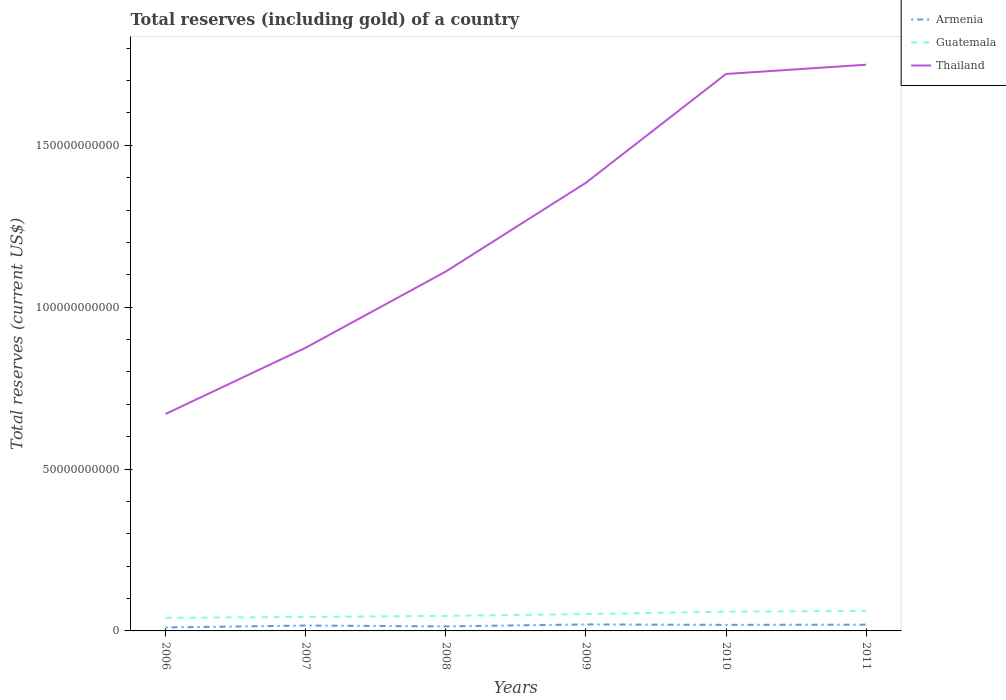Does the line corresponding to Armenia intersect with the line corresponding to Thailand?
Provide a succinct answer. No. Is the number of lines equal to the number of legend labels?
Your response must be concise. Yes. Across all years, what is the maximum total reserves (including gold) in Guatemala?
Your answer should be compact. 4.06e+09. What is the total total reserves (including gold) in Thailand in the graph?
Your response must be concise. -8.74e+1. What is the difference between the highest and the second highest total reserves (including gold) in Armenia?
Make the answer very short. 9.32e+08. How many lines are there?
Provide a succinct answer. 3. How many years are there in the graph?
Keep it short and to the point. 6. What is the difference between two consecutive major ticks on the Y-axis?
Your answer should be very brief. 5.00e+1. Are the values on the major ticks of Y-axis written in scientific E-notation?
Provide a succinct answer. No. Does the graph contain any zero values?
Give a very brief answer. No. Does the graph contain grids?
Provide a short and direct response. No. What is the title of the graph?
Give a very brief answer. Total reserves (including gold) of a country. Does "Iraq" appear as one of the legend labels in the graph?
Give a very brief answer. No. What is the label or title of the Y-axis?
Your response must be concise. Total reserves (current US$). What is the Total reserves (current US$) in Armenia in 2006?
Keep it short and to the point. 1.07e+09. What is the Total reserves (current US$) in Guatemala in 2006?
Give a very brief answer. 4.06e+09. What is the Total reserves (current US$) of Thailand in 2006?
Ensure brevity in your answer.  6.70e+1. What is the Total reserves (current US$) in Armenia in 2007?
Your answer should be compact. 1.66e+09. What is the Total reserves (current US$) of Guatemala in 2007?
Keep it short and to the point. 4.31e+09. What is the Total reserves (current US$) in Thailand in 2007?
Your answer should be very brief. 8.75e+1. What is the Total reserves (current US$) of Armenia in 2008?
Provide a succinct answer. 1.41e+09. What is the Total reserves (current US$) of Guatemala in 2008?
Make the answer very short. 4.65e+09. What is the Total reserves (current US$) of Thailand in 2008?
Provide a short and direct response. 1.11e+11. What is the Total reserves (current US$) of Armenia in 2009?
Give a very brief answer. 2.00e+09. What is the Total reserves (current US$) of Guatemala in 2009?
Your answer should be very brief. 5.20e+09. What is the Total reserves (current US$) in Thailand in 2009?
Provide a short and direct response. 1.38e+11. What is the Total reserves (current US$) of Armenia in 2010?
Offer a terse response. 1.87e+09. What is the Total reserves (current US$) of Guatemala in 2010?
Ensure brevity in your answer.  5.95e+09. What is the Total reserves (current US$) in Thailand in 2010?
Your response must be concise. 1.72e+11. What is the Total reserves (current US$) in Armenia in 2011?
Offer a terse response. 1.93e+09. What is the Total reserves (current US$) in Guatemala in 2011?
Ensure brevity in your answer.  6.17e+09. What is the Total reserves (current US$) of Thailand in 2011?
Make the answer very short. 1.75e+11. Across all years, what is the maximum Total reserves (current US$) of Armenia?
Ensure brevity in your answer.  2.00e+09. Across all years, what is the maximum Total reserves (current US$) of Guatemala?
Your answer should be compact. 6.17e+09. Across all years, what is the maximum Total reserves (current US$) of Thailand?
Make the answer very short. 1.75e+11. Across all years, what is the minimum Total reserves (current US$) of Armenia?
Provide a short and direct response. 1.07e+09. Across all years, what is the minimum Total reserves (current US$) of Guatemala?
Offer a very short reply. 4.06e+09. Across all years, what is the minimum Total reserves (current US$) in Thailand?
Offer a terse response. 6.70e+1. What is the total Total reserves (current US$) in Armenia in the graph?
Provide a succinct answer. 9.94e+09. What is the total Total reserves (current US$) in Guatemala in the graph?
Offer a very short reply. 3.04e+1. What is the total Total reserves (current US$) of Thailand in the graph?
Your answer should be compact. 7.51e+11. What is the difference between the Total reserves (current US$) of Armenia in 2006 and that in 2007?
Provide a short and direct response. -5.87e+08. What is the difference between the Total reserves (current US$) of Guatemala in 2006 and that in 2007?
Keep it short and to the point. -2.59e+08. What is the difference between the Total reserves (current US$) in Thailand in 2006 and that in 2007?
Keep it short and to the point. -2.05e+1. What is the difference between the Total reserves (current US$) of Armenia in 2006 and that in 2008?
Make the answer very short. -3.35e+08. What is the difference between the Total reserves (current US$) of Guatemala in 2006 and that in 2008?
Make the answer very short. -5.99e+08. What is the difference between the Total reserves (current US$) in Thailand in 2006 and that in 2008?
Provide a short and direct response. -4.40e+1. What is the difference between the Total reserves (current US$) in Armenia in 2006 and that in 2009?
Your answer should be very brief. -9.32e+08. What is the difference between the Total reserves (current US$) in Guatemala in 2006 and that in 2009?
Your answer should be compact. -1.15e+09. What is the difference between the Total reserves (current US$) in Thailand in 2006 and that in 2009?
Make the answer very short. -7.14e+1. What is the difference between the Total reserves (current US$) of Armenia in 2006 and that in 2010?
Your answer should be compact. -7.94e+08. What is the difference between the Total reserves (current US$) in Guatemala in 2006 and that in 2010?
Provide a short and direct response. -1.89e+09. What is the difference between the Total reserves (current US$) of Thailand in 2006 and that in 2010?
Your answer should be compact. -1.05e+11. What is the difference between the Total reserves (current US$) of Armenia in 2006 and that in 2011?
Make the answer very short. -8.61e+08. What is the difference between the Total reserves (current US$) in Guatemala in 2006 and that in 2011?
Give a very brief answer. -2.12e+09. What is the difference between the Total reserves (current US$) in Thailand in 2006 and that in 2011?
Your response must be concise. -1.08e+11. What is the difference between the Total reserves (current US$) of Armenia in 2007 and that in 2008?
Your answer should be very brief. 2.52e+08. What is the difference between the Total reserves (current US$) of Guatemala in 2007 and that in 2008?
Your answer should be compact. -3.39e+08. What is the difference between the Total reserves (current US$) of Thailand in 2007 and that in 2008?
Give a very brief answer. -2.35e+1. What is the difference between the Total reserves (current US$) in Armenia in 2007 and that in 2009?
Your response must be concise. -3.45e+08. What is the difference between the Total reserves (current US$) in Guatemala in 2007 and that in 2009?
Your response must be concise. -8.90e+08. What is the difference between the Total reserves (current US$) of Thailand in 2007 and that in 2009?
Your answer should be very brief. -5.09e+1. What is the difference between the Total reserves (current US$) in Armenia in 2007 and that in 2010?
Make the answer very short. -2.07e+08. What is the difference between the Total reserves (current US$) in Guatemala in 2007 and that in 2010?
Give a very brief answer. -1.63e+09. What is the difference between the Total reserves (current US$) of Thailand in 2007 and that in 2010?
Your answer should be very brief. -8.46e+1. What is the difference between the Total reserves (current US$) of Armenia in 2007 and that in 2011?
Your answer should be compact. -2.73e+08. What is the difference between the Total reserves (current US$) in Guatemala in 2007 and that in 2011?
Offer a terse response. -1.86e+09. What is the difference between the Total reserves (current US$) in Thailand in 2007 and that in 2011?
Make the answer very short. -8.74e+1. What is the difference between the Total reserves (current US$) in Armenia in 2008 and that in 2009?
Offer a terse response. -5.97e+08. What is the difference between the Total reserves (current US$) of Guatemala in 2008 and that in 2009?
Offer a very short reply. -5.51e+08. What is the difference between the Total reserves (current US$) of Thailand in 2008 and that in 2009?
Ensure brevity in your answer.  -2.74e+1. What is the difference between the Total reserves (current US$) of Armenia in 2008 and that in 2010?
Offer a terse response. -4.59e+08. What is the difference between the Total reserves (current US$) in Guatemala in 2008 and that in 2010?
Give a very brief answer. -1.29e+09. What is the difference between the Total reserves (current US$) in Thailand in 2008 and that in 2010?
Provide a succinct answer. -6.10e+1. What is the difference between the Total reserves (current US$) in Armenia in 2008 and that in 2011?
Offer a very short reply. -5.26e+08. What is the difference between the Total reserves (current US$) in Guatemala in 2008 and that in 2011?
Give a very brief answer. -1.52e+09. What is the difference between the Total reserves (current US$) of Thailand in 2008 and that in 2011?
Offer a terse response. -6.39e+1. What is the difference between the Total reserves (current US$) of Armenia in 2009 and that in 2010?
Provide a succinct answer. 1.38e+08. What is the difference between the Total reserves (current US$) of Guatemala in 2009 and that in 2010?
Offer a very short reply. -7.44e+08. What is the difference between the Total reserves (current US$) of Thailand in 2009 and that in 2010?
Your answer should be compact. -3.36e+1. What is the difference between the Total reserves (current US$) of Armenia in 2009 and that in 2011?
Ensure brevity in your answer.  7.12e+07. What is the difference between the Total reserves (current US$) in Guatemala in 2009 and that in 2011?
Provide a short and direct response. -9.69e+08. What is the difference between the Total reserves (current US$) in Thailand in 2009 and that in 2011?
Your response must be concise. -3.65e+1. What is the difference between the Total reserves (current US$) in Armenia in 2010 and that in 2011?
Provide a succinct answer. -6.66e+07. What is the difference between the Total reserves (current US$) in Guatemala in 2010 and that in 2011?
Your answer should be compact. -2.26e+08. What is the difference between the Total reserves (current US$) of Thailand in 2010 and that in 2011?
Offer a terse response. -2.86e+09. What is the difference between the Total reserves (current US$) of Armenia in 2006 and the Total reserves (current US$) of Guatemala in 2007?
Your response must be concise. -3.24e+09. What is the difference between the Total reserves (current US$) in Armenia in 2006 and the Total reserves (current US$) in Thailand in 2007?
Give a very brief answer. -8.64e+1. What is the difference between the Total reserves (current US$) of Guatemala in 2006 and the Total reserves (current US$) of Thailand in 2007?
Your response must be concise. -8.34e+1. What is the difference between the Total reserves (current US$) of Armenia in 2006 and the Total reserves (current US$) of Guatemala in 2008?
Provide a short and direct response. -3.58e+09. What is the difference between the Total reserves (current US$) in Armenia in 2006 and the Total reserves (current US$) in Thailand in 2008?
Provide a short and direct response. -1.10e+11. What is the difference between the Total reserves (current US$) in Guatemala in 2006 and the Total reserves (current US$) in Thailand in 2008?
Make the answer very short. -1.07e+11. What is the difference between the Total reserves (current US$) in Armenia in 2006 and the Total reserves (current US$) in Guatemala in 2009?
Give a very brief answer. -4.13e+09. What is the difference between the Total reserves (current US$) in Armenia in 2006 and the Total reserves (current US$) in Thailand in 2009?
Offer a very short reply. -1.37e+11. What is the difference between the Total reserves (current US$) in Guatemala in 2006 and the Total reserves (current US$) in Thailand in 2009?
Provide a short and direct response. -1.34e+11. What is the difference between the Total reserves (current US$) in Armenia in 2006 and the Total reserves (current US$) in Guatemala in 2010?
Provide a short and direct response. -4.88e+09. What is the difference between the Total reserves (current US$) in Armenia in 2006 and the Total reserves (current US$) in Thailand in 2010?
Keep it short and to the point. -1.71e+11. What is the difference between the Total reserves (current US$) of Guatemala in 2006 and the Total reserves (current US$) of Thailand in 2010?
Your answer should be compact. -1.68e+11. What is the difference between the Total reserves (current US$) in Armenia in 2006 and the Total reserves (current US$) in Guatemala in 2011?
Offer a terse response. -5.10e+09. What is the difference between the Total reserves (current US$) of Armenia in 2006 and the Total reserves (current US$) of Thailand in 2011?
Your answer should be compact. -1.74e+11. What is the difference between the Total reserves (current US$) of Guatemala in 2006 and the Total reserves (current US$) of Thailand in 2011?
Provide a short and direct response. -1.71e+11. What is the difference between the Total reserves (current US$) in Armenia in 2007 and the Total reserves (current US$) in Guatemala in 2008?
Your answer should be compact. -2.99e+09. What is the difference between the Total reserves (current US$) in Armenia in 2007 and the Total reserves (current US$) in Thailand in 2008?
Keep it short and to the point. -1.09e+11. What is the difference between the Total reserves (current US$) in Guatemala in 2007 and the Total reserves (current US$) in Thailand in 2008?
Your answer should be very brief. -1.07e+11. What is the difference between the Total reserves (current US$) in Armenia in 2007 and the Total reserves (current US$) in Guatemala in 2009?
Offer a very short reply. -3.55e+09. What is the difference between the Total reserves (current US$) of Armenia in 2007 and the Total reserves (current US$) of Thailand in 2009?
Your response must be concise. -1.37e+11. What is the difference between the Total reserves (current US$) of Guatemala in 2007 and the Total reserves (current US$) of Thailand in 2009?
Your answer should be very brief. -1.34e+11. What is the difference between the Total reserves (current US$) of Armenia in 2007 and the Total reserves (current US$) of Guatemala in 2010?
Keep it short and to the point. -4.29e+09. What is the difference between the Total reserves (current US$) of Armenia in 2007 and the Total reserves (current US$) of Thailand in 2010?
Offer a very short reply. -1.70e+11. What is the difference between the Total reserves (current US$) of Guatemala in 2007 and the Total reserves (current US$) of Thailand in 2010?
Provide a short and direct response. -1.68e+11. What is the difference between the Total reserves (current US$) of Armenia in 2007 and the Total reserves (current US$) of Guatemala in 2011?
Provide a succinct answer. -4.52e+09. What is the difference between the Total reserves (current US$) in Armenia in 2007 and the Total reserves (current US$) in Thailand in 2011?
Your answer should be compact. -1.73e+11. What is the difference between the Total reserves (current US$) of Guatemala in 2007 and the Total reserves (current US$) of Thailand in 2011?
Your response must be concise. -1.71e+11. What is the difference between the Total reserves (current US$) in Armenia in 2008 and the Total reserves (current US$) in Guatemala in 2009?
Offer a terse response. -3.80e+09. What is the difference between the Total reserves (current US$) in Armenia in 2008 and the Total reserves (current US$) in Thailand in 2009?
Offer a very short reply. -1.37e+11. What is the difference between the Total reserves (current US$) in Guatemala in 2008 and the Total reserves (current US$) in Thailand in 2009?
Give a very brief answer. -1.34e+11. What is the difference between the Total reserves (current US$) in Armenia in 2008 and the Total reserves (current US$) in Guatemala in 2010?
Your answer should be very brief. -4.54e+09. What is the difference between the Total reserves (current US$) of Armenia in 2008 and the Total reserves (current US$) of Thailand in 2010?
Your response must be concise. -1.71e+11. What is the difference between the Total reserves (current US$) of Guatemala in 2008 and the Total reserves (current US$) of Thailand in 2010?
Provide a succinct answer. -1.67e+11. What is the difference between the Total reserves (current US$) of Armenia in 2008 and the Total reserves (current US$) of Guatemala in 2011?
Your response must be concise. -4.77e+09. What is the difference between the Total reserves (current US$) of Armenia in 2008 and the Total reserves (current US$) of Thailand in 2011?
Make the answer very short. -1.73e+11. What is the difference between the Total reserves (current US$) of Guatemala in 2008 and the Total reserves (current US$) of Thailand in 2011?
Keep it short and to the point. -1.70e+11. What is the difference between the Total reserves (current US$) of Armenia in 2009 and the Total reserves (current US$) of Guatemala in 2010?
Make the answer very short. -3.94e+09. What is the difference between the Total reserves (current US$) of Armenia in 2009 and the Total reserves (current US$) of Thailand in 2010?
Offer a terse response. -1.70e+11. What is the difference between the Total reserves (current US$) in Guatemala in 2009 and the Total reserves (current US$) in Thailand in 2010?
Provide a succinct answer. -1.67e+11. What is the difference between the Total reserves (current US$) of Armenia in 2009 and the Total reserves (current US$) of Guatemala in 2011?
Give a very brief answer. -4.17e+09. What is the difference between the Total reserves (current US$) in Armenia in 2009 and the Total reserves (current US$) in Thailand in 2011?
Offer a very short reply. -1.73e+11. What is the difference between the Total reserves (current US$) of Guatemala in 2009 and the Total reserves (current US$) of Thailand in 2011?
Provide a short and direct response. -1.70e+11. What is the difference between the Total reserves (current US$) in Armenia in 2010 and the Total reserves (current US$) in Guatemala in 2011?
Your answer should be very brief. -4.31e+09. What is the difference between the Total reserves (current US$) of Armenia in 2010 and the Total reserves (current US$) of Thailand in 2011?
Provide a succinct answer. -1.73e+11. What is the difference between the Total reserves (current US$) of Guatemala in 2010 and the Total reserves (current US$) of Thailand in 2011?
Provide a succinct answer. -1.69e+11. What is the average Total reserves (current US$) of Armenia per year?
Ensure brevity in your answer.  1.66e+09. What is the average Total reserves (current US$) in Guatemala per year?
Make the answer very short. 5.06e+09. What is the average Total reserves (current US$) in Thailand per year?
Offer a terse response. 1.25e+11. In the year 2006, what is the difference between the Total reserves (current US$) of Armenia and Total reserves (current US$) of Guatemala?
Your response must be concise. -2.98e+09. In the year 2006, what is the difference between the Total reserves (current US$) of Armenia and Total reserves (current US$) of Thailand?
Your response must be concise. -6.59e+1. In the year 2006, what is the difference between the Total reserves (current US$) in Guatemala and Total reserves (current US$) in Thailand?
Ensure brevity in your answer.  -6.30e+1. In the year 2007, what is the difference between the Total reserves (current US$) in Armenia and Total reserves (current US$) in Guatemala?
Offer a terse response. -2.66e+09. In the year 2007, what is the difference between the Total reserves (current US$) in Armenia and Total reserves (current US$) in Thailand?
Provide a short and direct response. -8.58e+1. In the year 2007, what is the difference between the Total reserves (current US$) of Guatemala and Total reserves (current US$) of Thailand?
Keep it short and to the point. -8.32e+1. In the year 2008, what is the difference between the Total reserves (current US$) of Armenia and Total reserves (current US$) of Guatemala?
Offer a terse response. -3.25e+09. In the year 2008, what is the difference between the Total reserves (current US$) in Armenia and Total reserves (current US$) in Thailand?
Ensure brevity in your answer.  -1.10e+11. In the year 2008, what is the difference between the Total reserves (current US$) in Guatemala and Total reserves (current US$) in Thailand?
Your answer should be very brief. -1.06e+11. In the year 2009, what is the difference between the Total reserves (current US$) in Armenia and Total reserves (current US$) in Guatemala?
Your response must be concise. -3.20e+09. In the year 2009, what is the difference between the Total reserves (current US$) of Armenia and Total reserves (current US$) of Thailand?
Ensure brevity in your answer.  -1.36e+11. In the year 2009, what is the difference between the Total reserves (current US$) in Guatemala and Total reserves (current US$) in Thailand?
Make the answer very short. -1.33e+11. In the year 2010, what is the difference between the Total reserves (current US$) in Armenia and Total reserves (current US$) in Guatemala?
Your answer should be compact. -4.08e+09. In the year 2010, what is the difference between the Total reserves (current US$) in Armenia and Total reserves (current US$) in Thailand?
Keep it short and to the point. -1.70e+11. In the year 2010, what is the difference between the Total reserves (current US$) in Guatemala and Total reserves (current US$) in Thailand?
Give a very brief answer. -1.66e+11. In the year 2011, what is the difference between the Total reserves (current US$) of Armenia and Total reserves (current US$) of Guatemala?
Give a very brief answer. -4.24e+09. In the year 2011, what is the difference between the Total reserves (current US$) of Armenia and Total reserves (current US$) of Thailand?
Give a very brief answer. -1.73e+11. In the year 2011, what is the difference between the Total reserves (current US$) in Guatemala and Total reserves (current US$) in Thailand?
Provide a short and direct response. -1.69e+11. What is the ratio of the Total reserves (current US$) in Armenia in 2006 to that in 2007?
Offer a terse response. 0.65. What is the ratio of the Total reserves (current US$) in Guatemala in 2006 to that in 2007?
Give a very brief answer. 0.94. What is the ratio of the Total reserves (current US$) of Thailand in 2006 to that in 2007?
Your answer should be compact. 0.77. What is the ratio of the Total reserves (current US$) in Armenia in 2006 to that in 2008?
Your answer should be compact. 0.76. What is the ratio of the Total reserves (current US$) in Guatemala in 2006 to that in 2008?
Give a very brief answer. 0.87. What is the ratio of the Total reserves (current US$) of Thailand in 2006 to that in 2008?
Offer a terse response. 0.6. What is the ratio of the Total reserves (current US$) in Armenia in 2006 to that in 2009?
Your answer should be compact. 0.54. What is the ratio of the Total reserves (current US$) in Guatemala in 2006 to that in 2009?
Offer a terse response. 0.78. What is the ratio of the Total reserves (current US$) in Thailand in 2006 to that in 2009?
Provide a short and direct response. 0.48. What is the ratio of the Total reserves (current US$) of Armenia in 2006 to that in 2010?
Keep it short and to the point. 0.57. What is the ratio of the Total reserves (current US$) of Guatemala in 2006 to that in 2010?
Make the answer very short. 0.68. What is the ratio of the Total reserves (current US$) in Thailand in 2006 to that in 2010?
Offer a terse response. 0.39. What is the ratio of the Total reserves (current US$) in Armenia in 2006 to that in 2011?
Provide a succinct answer. 0.55. What is the ratio of the Total reserves (current US$) of Guatemala in 2006 to that in 2011?
Your answer should be compact. 0.66. What is the ratio of the Total reserves (current US$) of Thailand in 2006 to that in 2011?
Give a very brief answer. 0.38. What is the ratio of the Total reserves (current US$) in Armenia in 2007 to that in 2008?
Keep it short and to the point. 1.18. What is the ratio of the Total reserves (current US$) in Guatemala in 2007 to that in 2008?
Make the answer very short. 0.93. What is the ratio of the Total reserves (current US$) in Thailand in 2007 to that in 2008?
Offer a terse response. 0.79. What is the ratio of the Total reserves (current US$) in Armenia in 2007 to that in 2009?
Give a very brief answer. 0.83. What is the ratio of the Total reserves (current US$) of Guatemala in 2007 to that in 2009?
Your response must be concise. 0.83. What is the ratio of the Total reserves (current US$) of Thailand in 2007 to that in 2009?
Offer a terse response. 0.63. What is the ratio of the Total reserves (current US$) of Armenia in 2007 to that in 2010?
Make the answer very short. 0.89. What is the ratio of the Total reserves (current US$) in Guatemala in 2007 to that in 2010?
Offer a very short reply. 0.73. What is the ratio of the Total reserves (current US$) of Thailand in 2007 to that in 2010?
Provide a succinct answer. 0.51. What is the ratio of the Total reserves (current US$) of Armenia in 2007 to that in 2011?
Ensure brevity in your answer.  0.86. What is the ratio of the Total reserves (current US$) in Guatemala in 2007 to that in 2011?
Your answer should be compact. 0.7. What is the ratio of the Total reserves (current US$) of Thailand in 2007 to that in 2011?
Your answer should be compact. 0.5. What is the ratio of the Total reserves (current US$) in Armenia in 2008 to that in 2009?
Your answer should be compact. 0.7. What is the ratio of the Total reserves (current US$) in Guatemala in 2008 to that in 2009?
Your response must be concise. 0.89. What is the ratio of the Total reserves (current US$) of Thailand in 2008 to that in 2009?
Your response must be concise. 0.8. What is the ratio of the Total reserves (current US$) of Armenia in 2008 to that in 2010?
Give a very brief answer. 0.75. What is the ratio of the Total reserves (current US$) of Guatemala in 2008 to that in 2010?
Offer a very short reply. 0.78. What is the ratio of the Total reserves (current US$) in Thailand in 2008 to that in 2010?
Your answer should be very brief. 0.65. What is the ratio of the Total reserves (current US$) in Armenia in 2008 to that in 2011?
Your answer should be very brief. 0.73. What is the ratio of the Total reserves (current US$) of Guatemala in 2008 to that in 2011?
Provide a short and direct response. 0.75. What is the ratio of the Total reserves (current US$) in Thailand in 2008 to that in 2011?
Keep it short and to the point. 0.63. What is the ratio of the Total reserves (current US$) of Armenia in 2009 to that in 2010?
Make the answer very short. 1.07. What is the ratio of the Total reserves (current US$) in Thailand in 2009 to that in 2010?
Your answer should be very brief. 0.8. What is the ratio of the Total reserves (current US$) in Armenia in 2009 to that in 2011?
Give a very brief answer. 1.04. What is the ratio of the Total reserves (current US$) in Guatemala in 2009 to that in 2011?
Offer a terse response. 0.84. What is the ratio of the Total reserves (current US$) in Thailand in 2009 to that in 2011?
Your response must be concise. 0.79. What is the ratio of the Total reserves (current US$) of Armenia in 2010 to that in 2011?
Your response must be concise. 0.97. What is the ratio of the Total reserves (current US$) in Guatemala in 2010 to that in 2011?
Offer a very short reply. 0.96. What is the ratio of the Total reserves (current US$) in Thailand in 2010 to that in 2011?
Give a very brief answer. 0.98. What is the difference between the highest and the second highest Total reserves (current US$) in Armenia?
Provide a short and direct response. 7.12e+07. What is the difference between the highest and the second highest Total reserves (current US$) of Guatemala?
Your answer should be compact. 2.26e+08. What is the difference between the highest and the second highest Total reserves (current US$) in Thailand?
Your answer should be compact. 2.86e+09. What is the difference between the highest and the lowest Total reserves (current US$) of Armenia?
Provide a short and direct response. 9.32e+08. What is the difference between the highest and the lowest Total reserves (current US$) of Guatemala?
Your answer should be compact. 2.12e+09. What is the difference between the highest and the lowest Total reserves (current US$) of Thailand?
Offer a terse response. 1.08e+11. 